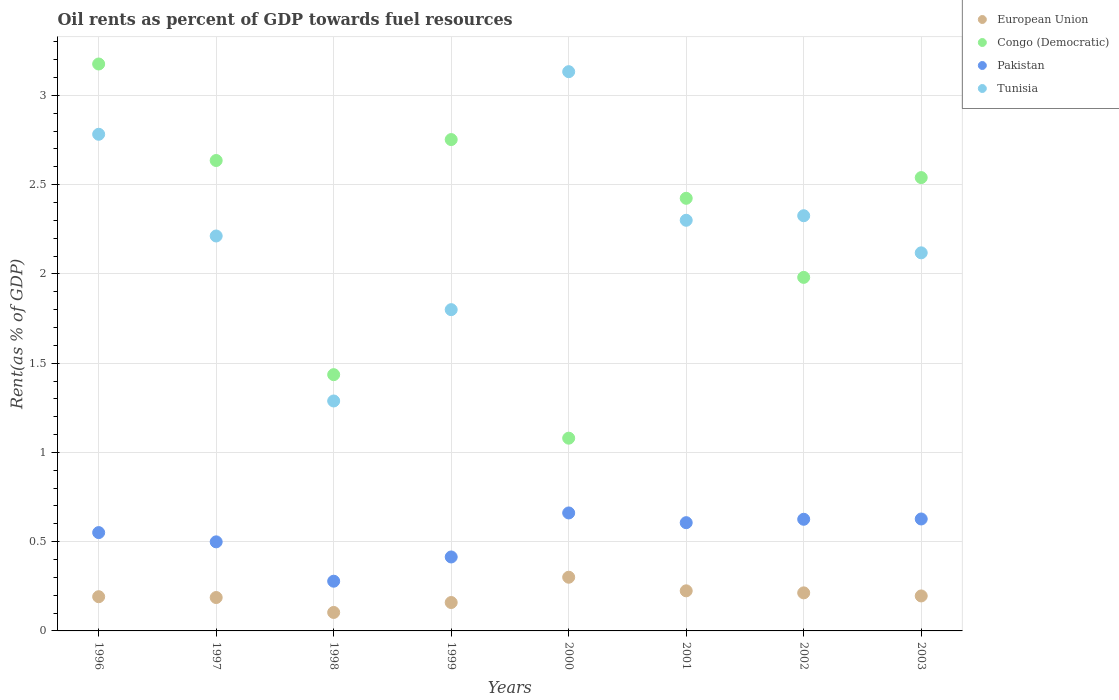What is the oil rent in European Union in 1998?
Offer a terse response. 0.1. Across all years, what is the maximum oil rent in Tunisia?
Provide a short and direct response. 3.13. Across all years, what is the minimum oil rent in Pakistan?
Offer a terse response. 0.28. In which year was the oil rent in Tunisia maximum?
Provide a short and direct response. 2000. In which year was the oil rent in Congo (Democratic) minimum?
Offer a very short reply. 2000. What is the total oil rent in Tunisia in the graph?
Your response must be concise. 17.96. What is the difference between the oil rent in European Union in 1997 and that in 2003?
Your answer should be compact. -0.01. What is the difference between the oil rent in Congo (Democratic) in 1998 and the oil rent in European Union in 2001?
Make the answer very short. 1.21. What is the average oil rent in Congo (Democratic) per year?
Your response must be concise. 2.25. In the year 2002, what is the difference between the oil rent in Pakistan and oil rent in Tunisia?
Your response must be concise. -1.7. In how many years, is the oil rent in Pakistan greater than 2.1 %?
Provide a succinct answer. 0. What is the ratio of the oil rent in Pakistan in 1998 to that in 2001?
Provide a succinct answer. 0.46. Is the oil rent in Pakistan in 1999 less than that in 2002?
Provide a succinct answer. Yes. Is the difference between the oil rent in Pakistan in 1996 and 1999 greater than the difference between the oil rent in Tunisia in 1996 and 1999?
Offer a very short reply. No. What is the difference between the highest and the second highest oil rent in European Union?
Ensure brevity in your answer.  0.08. What is the difference between the highest and the lowest oil rent in European Union?
Ensure brevity in your answer.  0.2. In how many years, is the oil rent in European Union greater than the average oil rent in European Union taken over all years?
Offer a very short reply. 3. Is it the case that in every year, the sum of the oil rent in Congo (Democratic) and oil rent in European Union  is greater than the sum of oil rent in Tunisia and oil rent in Pakistan?
Offer a terse response. No. Is the oil rent in Pakistan strictly less than the oil rent in European Union over the years?
Offer a very short reply. No. How many dotlines are there?
Make the answer very short. 4. What is the difference between two consecutive major ticks on the Y-axis?
Make the answer very short. 0.5. Does the graph contain any zero values?
Your response must be concise. No. Does the graph contain grids?
Provide a succinct answer. Yes. What is the title of the graph?
Your response must be concise. Oil rents as percent of GDP towards fuel resources. Does "Pakistan" appear as one of the legend labels in the graph?
Keep it short and to the point. Yes. What is the label or title of the Y-axis?
Make the answer very short. Rent(as % of GDP). What is the Rent(as % of GDP) in European Union in 1996?
Give a very brief answer. 0.19. What is the Rent(as % of GDP) in Congo (Democratic) in 1996?
Keep it short and to the point. 3.18. What is the Rent(as % of GDP) in Pakistan in 1996?
Offer a very short reply. 0.55. What is the Rent(as % of GDP) in Tunisia in 1996?
Offer a very short reply. 2.78. What is the Rent(as % of GDP) of European Union in 1997?
Offer a very short reply. 0.19. What is the Rent(as % of GDP) in Congo (Democratic) in 1997?
Provide a succinct answer. 2.64. What is the Rent(as % of GDP) in Pakistan in 1997?
Give a very brief answer. 0.5. What is the Rent(as % of GDP) in Tunisia in 1997?
Your answer should be compact. 2.21. What is the Rent(as % of GDP) in European Union in 1998?
Your answer should be compact. 0.1. What is the Rent(as % of GDP) of Congo (Democratic) in 1998?
Offer a very short reply. 1.44. What is the Rent(as % of GDP) of Pakistan in 1998?
Provide a short and direct response. 0.28. What is the Rent(as % of GDP) in Tunisia in 1998?
Your response must be concise. 1.29. What is the Rent(as % of GDP) of European Union in 1999?
Provide a short and direct response. 0.16. What is the Rent(as % of GDP) of Congo (Democratic) in 1999?
Your answer should be very brief. 2.75. What is the Rent(as % of GDP) of Pakistan in 1999?
Keep it short and to the point. 0.41. What is the Rent(as % of GDP) in Tunisia in 1999?
Offer a very short reply. 1.8. What is the Rent(as % of GDP) in European Union in 2000?
Your response must be concise. 0.3. What is the Rent(as % of GDP) of Congo (Democratic) in 2000?
Your answer should be very brief. 1.08. What is the Rent(as % of GDP) of Pakistan in 2000?
Offer a very short reply. 0.66. What is the Rent(as % of GDP) of Tunisia in 2000?
Keep it short and to the point. 3.13. What is the Rent(as % of GDP) in European Union in 2001?
Provide a short and direct response. 0.22. What is the Rent(as % of GDP) of Congo (Democratic) in 2001?
Offer a very short reply. 2.42. What is the Rent(as % of GDP) in Pakistan in 2001?
Keep it short and to the point. 0.61. What is the Rent(as % of GDP) of Tunisia in 2001?
Your response must be concise. 2.3. What is the Rent(as % of GDP) of European Union in 2002?
Make the answer very short. 0.21. What is the Rent(as % of GDP) in Congo (Democratic) in 2002?
Make the answer very short. 1.98. What is the Rent(as % of GDP) of Pakistan in 2002?
Your answer should be very brief. 0.63. What is the Rent(as % of GDP) in Tunisia in 2002?
Your answer should be very brief. 2.33. What is the Rent(as % of GDP) in European Union in 2003?
Your response must be concise. 0.2. What is the Rent(as % of GDP) in Congo (Democratic) in 2003?
Ensure brevity in your answer.  2.54. What is the Rent(as % of GDP) of Pakistan in 2003?
Your answer should be very brief. 0.63. What is the Rent(as % of GDP) in Tunisia in 2003?
Provide a short and direct response. 2.12. Across all years, what is the maximum Rent(as % of GDP) of European Union?
Offer a terse response. 0.3. Across all years, what is the maximum Rent(as % of GDP) in Congo (Democratic)?
Keep it short and to the point. 3.18. Across all years, what is the maximum Rent(as % of GDP) in Pakistan?
Make the answer very short. 0.66. Across all years, what is the maximum Rent(as % of GDP) of Tunisia?
Ensure brevity in your answer.  3.13. Across all years, what is the minimum Rent(as % of GDP) of European Union?
Your answer should be very brief. 0.1. Across all years, what is the minimum Rent(as % of GDP) of Congo (Democratic)?
Make the answer very short. 1.08. Across all years, what is the minimum Rent(as % of GDP) of Pakistan?
Your response must be concise. 0.28. Across all years, what is the minimum Rent(as % of GDP) in Tunisia?
Keep it short and to the point. 1.29. What is the total Rent(as % of GDP) in European Union in the graph?
Ensure brevity in your answer.  1.58. What is the total Rent(as % of GDP) of Congo (Democratic) in the graph?
Your answer should be compact. 18.02. What is the total Rent(as % of GDP) of Pakistan in the graph?
Keep it short and to the point. 4.26. What is the total Rent(as % of GDP) of Tunisia in the graph?
Provide a succinct answer. 17.96. What is the difference between the Rent(as % of GDP) in European Union in 1996 and that in 1997?
Provide a short and direct response. 0. What is the difference between the Rent(as % of GDP) of Congo (Democratic) in 1996 and that in 1997?
Provide a succinct answer. 0.54. What is the difference between the Rent(as % of GDP) of Pakistan in 1996 and that in 1997?
Provide a short and direct response. 0.05. What is the difference between the Rent(as % of GDP) of Tunisia in 1996 and that in 1997?
Provide a succinct answer. 0.57. What is the difference between the Rent(as % of GDP) in European Union in 1996 and that in 1998?
Ensure brevity in your answer.  0.09. What is the difference between the Rent(as % of GDP) in Congo (Democratic) in 1996 and that in 1998?
Provide a short and direct response. 1.74. What is the difference between the Rent(as % of GDP) of Pakistan in 1996 and that in 1998?
Your answer should be very brief. 0.27. What is the difference between the Rent(as % of GDP) of Tunisia in 1996 and that in 1998?
Offer a very short reply. 1.49. What is the difference between the Rent(as % of GDP) in European Union in 1996 and that in 1999?
Give a very brief answer. 0.03. What is the difference between the Rent(as % of GDP) of Congo (Democratic) in 1996 and that in 1999?
Provide a short and direct response. 0.42. What is the difference between the Rent(as % of GDP) of Pakistan in 1996 and that in 1999?
Your response must be concise. 0.14. What is the difference between the Rent(as % of GDP) of Tunisia in 1996 and that in 1999?
Offer a very short reply. 0.98. What is the difference between the Rent(as % of GDP) of European Union in 1996 and that in 2000?
Make the answer very short. -0.11. What is the difference between the Rent(as % of GDP) in Congo (Democratic) in 1996 and that in 2000?
Ensure brevity in your answer.  2.1. What is the difference between the Rent(as % of GDP) in Pakistan in 1996 and that in 2000?
Your response must be concise. -0.11. What is the difference between the Rent(as % of GDP) of Tunisia in 1996 and that in 2000?
Offer a terse response. -0.35. What is the difference between the Rent(as % of GDP) of European Union in 1996 and that in 2001?
Your answer should be compact. -0.03. What is the difference between the Rent(as % of GDP) in Congo (Democratic) in 1996 and that in 2001?
Offer a very short reply. 0.75. What is the difference between the Rent(as % of GDP) of Pakistan in 1996 and that in 2001?
Your response must be concise. -0.06. What is the difference between the Rent(as % of GDP) of Tunisia in 1996 and that in 2001?
Keep it short and to the point. 0.48. What is the difference between the Rent(as % of GDP) of European Union in 1996 and that in 2002?
Provide a short and direct response. -0.02. What is the difference between the Rent(as % of GDP) of Congo (Democratic) in 1996 and that in 2002?
Make the answer very short. 1.2. What is the difference between the Rent(as % of GDP) in Pakistan in 1996 and that in 2002?
Your response must be concise. -0.07. What is the difference between the Rent(as % of GDP) of Tunisia in 1996 and that in 2002?
Ensure brevity in your answer.  0.46. What is the difference between the Rent(as % of GDP) in European Union in 1996 and that in 2003?
Make the answer very short. -0. What is the difference between the Rent(as % of GDP) in Congo (Democratic) in 1996 and that in 2003?
Ensure brevity in your answer.  0.64. What is the difference between the Rent(as % of GDP) in Pakistan in 1996 and that in 2003?
Keep it short and to the point. -0.08. What is the difference between the Rent(as % of GDP) of Tunisia in 1996 and that in 2003?
Ensure brevity in your answer.  0.66. What is the difference between the Rent(as % of GDP) in European Union in 1997 and that in 1998?
Offer a terse response. 0.08. What is the difference between the Rent(as % of GDP) in Congo (Democratic) in 1997 and that in 1998?
Keep it short and to the point. 1.2. What is the difference between the Rent(as % of GDP) in Pakistan in 1997 and that in 1998?
Your answer should be compact. 0.22. What is the difference between the Rent(as % of GDP) in Tunisia in 1997 and that in 1998?
Offer a terse response. 0.92. What is the difference between the Rent(as % of GDP) of European Union in 1997 and that in 1999?
Make the answer very short. 0.03. What is the difference between the Rent(as % of GDP) in Congo (Democratic) in 1997 and that in 1999?
Offer a very short reply. -0.12. What is the difference between the Rent(as % of GDP) of Pakistan in 1997 and that in 1999?
Provide a succinct answer. 0.08. What is the difference between the Rent(as % of GDP) in Tunisia in 1997 and that in 1999?
Your answer should be compact. 0.41. What is the difference between the Rent(as % of GDP) in European Union in 1997 and that in 2000?
Your answer should be very brief. -0.11. What is the difference between the Rent(as % of GDP) of Congo (Democratic) in 1997 and that in 2000?
Provide a short and direct response. 1.56. What is the difference between the Rent(as % of GDP) in Pakistan in 1997 and that in 2000?
Provide a short and direct response. -0.16. What is the difference between the Rent(as % of GDP) of Tunisia in 1997 and that in 2000?
Ensure brevity in your answer.  -0.92. What is the difference between the Rent(as % of GDP) of European Union in 1997 and that in 2001?
Provide a short and direct response. -0.04. What is the difference between the Rent(as % of GDP) in Congo (Democratic) in 1997 and that in 2001?
Make the answer very short. 0.21. What is the difference between the Rent(as % of GDP) of Pakistan in 1997 and that in 2001?
Keep it short and to the point. -0.11. What is the difference between the Rent(as % of GDP) of Tunisia in 1997 and that in 2001?
Ensure brevity in your answer.  -0.09. What is the difference between the Rent(as % of GDP) of European Union in 1997 and that in 2002?
Ensure brevity in your answer.  -0.03. What is the difference between the Rent(as % of GDP) of Congo (Democratic) in 1997 and that in 2002?
Provide a short and direct response. 0.65. What is the difference between the Rent(as % of GDP) in Pakistan in 1997 and that in 2002?
Provide a short and direct response. -0.13. What is the difference between the Rent(as % of GDP) of Tunisia in 1997 and that in 2002?
Offer a very short reply. -0.11. What is the difference between the Rent(as % of GDP) of European Union in 1997 and that in 2003?
Give a very brief answer. -0.01. What is the difference between the Rent(as % of GDP) in Congo (Democratic) in 1997 and that in 2003?
Offer a very short reply. 0.1. What is the difference between the Rent(as % of GDP) in Pakistan in 1997 and that in 2003?
Provide a short and direct response. -0.13. What is the difference between the Rent(as % of GDP) in Tunisia in 1997 and that in 2003?
Your answer should be compact. 0.09. What is the difference between the Rent(as % of GDP) in European Union in 1998 and that in 1999?
Keep it short and to the point. -0.06. What is the difference between the Rent(as % of GDP) of Congo (Democratic) in 1998 and that in 1999?
Provide a short and direct response. -1.32. What is the difference between the Rent(as % of GDP) in Pakistan in 1998 and that in 1999?
Your answer should be compact. -0.14. What is the difference between the Rent(as % of GDP) in Tunisia in 1998 and that in 1999?
Provide a succinct answer. -0.51. What is the difference between the Rent(as % of GDP) in European Union in 1998 and that in 2000?
Ensure brevity in your answer.  -0.2. What is the difference between the Rent(as % of GDP) of Congo (Democratic) in 1998 and that in 2000?
Offer a terse response. 0.36. What is the difference between the Rent(as % of GDP) of Pakistan in 1998 and that in 2000?
Your response must be concise. -0.38. What is the difference between the Rent(as % of GDP) in Tunisia in 1998 and that in 2000?
Give a very brief answer. -1.84. What is the difference between the Rent(as % of GDP) of European Union in 1998 and that in 2001?
Your answer should be very brief. -0.12. What is the difference between the Rent(as % of GDP) of Congo (Democratic) in 1998 and that in 2001?
Your answer should be compact. -0.99. What is the difference between the Rent(as % of GDP) of Pakistan in 1998 and that in 2001?
Give a very brief answer. -0.33. What is the difference between the Rent(as % of GDP) in Tunisia in 1998 and that in 2001?
Provide a succinct answer. -1.01. What is the difference between the Rent(as % of GDP) of European Union in 1998 and that in 2002?
Offer a terse response. -0.11. What is the difference between the Rent(as % of GDP) of Congo (Democratic) in 1998 and that in 2002?
Your answer should be compact. -0.55. What is the difference between the Rent(as % of GDP) in Pakistan in 1998 and that in 2002?
Ensure brevity in your answer.  -0.35. What is the difference between the Rent(as % of GDP) in Tunisia in 1998 and that in 2002?
Offer a very short reply. -1.04. What is the difference between the Rent(as % of GDP) of European Union in 1998 and that in 2003?
Your response must be concise. -0.09. What is the difference between the Rent(as % of GDP) in Congo (Democratic) in 1998 and that in 2003?
Ensure brevity in your answer.  -1.1. What is the difference between the Rent(as % of GDP) of Pakistan in 1998 and that in 2003?
Offer a terse response. -0.35. What is the difference between the Rent(as % of GDP) of Tunisia in 1998 and that in 2003?
Offer a terse response. -0.83. What is the difference between the Rent(as % of GDP) in European Union in 1999 and that in 2000?
Your answer should be very brief. -0.14. What is the difference between the Rent(as % of GDP) in Congo (Democratic) in 1999 and that in 2000?
Give a very brief answer. 1.67. What is the difference between the Rent(as % of GDP) in Pakistan in 1999 and that in 2000?
Ensure brevity in your answer.  -0.25. What is the difference between the Rent(as % of GDP) in Tunisia in 1999 and that in 2000?
Give a very brief answer. -1.33. What is the difference between the Rent(as % of GDP) in European Union in 1999 and that in 2001?
Provide a short and direct response. -0.07. What is the difference between the Rent(as % of GDP) of Congo (Democratic) in 1999 and that in 2001?
Give a very brief answer. 0.33. What is the difference between the Rent(as % of GDP) in Pakistan in 1999 and that in 2001?
Keep it short and to the point. -0.19. What is the difference between the Rent(as % of GDP) in Tunisia in 1999 and that in 2001?
Keep it short and to the point. -0.5. What is the difference between the Rent(as % of GDP) of European Union in 1999 and that in 2002?
Your answer should be very brief. -0.05. What is the difference between the Rent(as % of GDP) in Congo (Democratic) in 1999 and that in 2002?
Provide a short and direct response. 0.77. What is the difference between the Rent(as % of GDP) of Pakistan in 1999 and that in 2002?
Keep it short and to the point. -0.21. What is the difference between the Rent(as % of GDP) in Tunisia in 1999 and that in 2002?
Your answer should be compact. -0.53. What is the difference between the Rent(as % of GDP) in European Union in 1999 and that in 2003?
Your response must be concise. -0.04. What is the difference between the Rent(as % of GDP) in Congo (Democratic) in 1999 and that in 2003?
Your answer should be very brief. 0.21. What is the difference between the Rent(as % of GDP) of Pakistan in 1999 and that in 2003?
Offer a very short reply. -0.21. What is the difference between the Rent(as % of GDP) of Tunisia in 1999 and that in 2003?
Provide a short and direct response. -0.32. What is the difference between the Rent(as % of GDP) of European Union in 2000 and that in 2001?
Provide a succinct answer. 0.08. What is the difference between the Rent(as % of GDP) in Congo (Democratic) in 2000 and that in 2001?
Your answer should be compact. -1.34. What is the difference between the Rent(as % of GDP) in Pakistan in 2000 and that in 2001?
Offer a terse response. 0.05. What is the difference between the Rent(as % of GDP) in Tunisia in 2000 and that in 2001?
Provide a succinct answer. 0.83. What is the difference between the Rent(as % of GDP) of European Union in 2000 and that in 2002?
Offer a very short reply. 0.09. What is the difference between the Rent(as % of GDP) in Congo (Democratic) in 2000 and that in 2002?
Keep it short and to the point. -0.9. What is the difference between the Rent(as % of GDP) of Pakistan in 2000 and that in 2002?
Offer a terse response. 0.04. What is the difference between the Rent(as % of GDP) of Tunisia in 2000 and that in 2002?
Offer a very short reply. 0.81. What is the difference between the Rent(as % of GDP) in European Union in 2000 and that in 2003?
Offer a terse response. 0.1. What is the difference between the Rent(as % of GDP) of Congo (Democratic) in 2000 and that in 2003?
Your answer should be very brief. -1.46. What is the difference between the Rent(as % of GDP) of Pakistan in 2000 and that in 2003?
Provide a short and direct response. 0.03. What is the difference between the Rent(as % of GDP) in Tunisia in 2000 and that in 2003?
Your answer should be compact. 1.01. What is the difference between the Rent(as % of GDP) in European Union in 2001 and that in 2002?
Your response must be concise. 0.01. What is the difference between the Rent(as % of GDP) in Congo (Democratic) in 2001 and that in 2002?
Make the answer very short. 0.44. What is the difference between the Rent(as % of GDP) of Pakistan in 2001 and that in 2002?
Your answer should be compact. -0.02. What is the difference between the Rent(as % of GDP) in Tunisia in 2001 and that in 2002?
Make the answer very short. -0.03. What is the difference between the Rent(as % of GDP) in European Union in 2001 and that in 2003?
Give a very brief answer. 0.03. What is the difference between the Rent(as % of GDP) of Congo (Democratic) in 2001 and that in 2003?
Give a very brief answer. -0.12. What is the difference between the Rent(as % of GDP) in Pakistan in 2001 and that in 2003?
Your answer should be very brief. -0.02. What is the difference between the Rent(as % of GDP) in Tunisia in 2001 and that in 2003?
Give a very brief answer. 0.18. What is the difference between the Rent(as % of GDP) in European Union in 2002 and that in 2003?
Offer a very short reply. 0.02. What is the difference between the Rent(as % of GDP) in Congo (Democratic) in 2002 and that in 2003?
Offer a terse response. -0.56. What is the difference between the Rent(as % of GDP) of Pakistan in 2002 and that in 2003?
Offer a very short reply. -0. What is the difference between the Rent(as % of GDP) of Tunisia in 2002 and that in 2003?
Provide a succinct answer. 0.21. What is the difference between the Rent(as % of GDP) in European Union in 1996 and the Rent(as % of GDP) in Congo (Democratic) in 1997?
Your answer should be very brief. -2.44. What is the difference between the Rent(as % of GDP) of European Union in 1996 and the Rent(as % of GDP) of Pakistan in 1997?
Make the answer very short. -0.31. What is the difference between the Rent(as % of GDP) in European Union in 1996 and the Rent(as % of GDP) in Tunisia in 1997?
Your answer should be compact. -2.02. What is the difference between the Rent(as % of GDP) in Congo (Democratic) in 1996 and the Rent(as % of GDP) in Pakistan in 1997?
Offer a very short reply. 2.68. What is the difference between the Rent(as % of GDP) in Congo (Democratic) in 1996 and the Rent(as % of GDP) in Tunisia in 1997?
Offer a terse response. 0.96. What is the difference between the Rent(as % of GDP) in Pakistan in 1996 and the Rent(as % of GDP) in Tunisia in 1997?
Provide a succinct answer. -1.66. What is the difference between the Rent(as % of GDP) in European Union in 1996 and the Rent(as % of GDP) in Congo (Democratic) in 1998?
Ensure brevity in your answer.  -1.24. What is the difference between the Rent(as % of GDP) of European Union in 1996 and the Rent(as % of GDP) of Pakistan in 1998?
Keep it short and to the point. -0.09. What is the difference between the Rent(as % of GDP) of European Union in 1996 and the Rent(as % of GDP) of Tunisia in 1998?
Provide a succinct answer. -1.1. What is the difference between the Rent(as % of GDP) in Congo (Democratic) in 1996 and the Rent(as % of GDP) in Pakistan in 1998?
Provide a short and direct response. 2.9. What is the difference between the Rent(as % of GDP) of Congo (Democratic) in 1996 and the Rent(as % of GDP) of Tunisia in 1998?
Offer a terse response. 1.89. What is the difference between the Rent(as % of GDP) of Pakistan in 1996 and the Rent(as % of GDP) of Tunisia in 1998?
Your response must be concise. -0.74. What is the difference between the Rent(as % of GDP) in European Union in 1996 and the Rent(as % of GDP) in Congo (Democratic) in 1999?
Provide a succinct answer. -2.56. What is the difference between the Rent(as % of GDP) in European Union in 1996 and the Rent(as % of GDP) in Pakistan in 1999?
Provide a short and direct response. -0.22. What is the difference between the Rent(as % of GDP) in European Union in 1996 and the Rent(as % of GDP) in Tunisia in 1999?
Offer a terse response. -1.61. What is the difference between the Rent(as % of GDP) of Congo (Democratic) in 1996 and the Rent(as % of GDP) of Pakistan in 1999?
Offer a terse response. 2.76. What is the difference between the Rent(as % of GDP) in Congo (Democratic) in 1996 and the Rent(as % of GDP) in Tunisia in 1999?
Your answer should be compact. 1.38. What is the difference between the Rent(as % of GDP) of Pakistan in 1996 and the Rent(as % of GDP) of Tunisia in 1999?
Offer a very short reply. -1.25. What is the difference between the Rent(as % of GDP) in European Union in 1996 and the Rent(as % of GDP) in Congo (Democratic) in 2000?
Give a very brief answer. -0.89. What is the difference between the Rent(as % of GDP) of European Union in 1996 and the Rent(as % of GDP) of Pakistan in 2000?
Your answer should be very brief. -0.47. What is the difference between the Rent(as % of GDP) of European Union in 1996 and the Rent(as % of GDP) of Tunisia in 2000?
Make the answer very short. -2.94. What is the difference between the Rent(as % of GDP) in Congo (Democratic) in 1996 and the Rent(as % of GDP) in Pakistan in 2000?
Keep it short and to the point. 2.51. What is the difference between the Rent(as % of GDP) in Congo (Democratic) in 1996 and the Rent(as % of GDP) in Tunisia in 2000?
Give a very brief answer. 0.04. What is the difference between the Rent(as % of GDP) in Pakistan in 1996 and the Rent(as % of GDP) in Tunisia in 2000?
Give a very brief answer. -2.58. What is the difference between the Rent(as % of GDP) of European Union in 1996 and the Rent(as % of GDP) of Congo (Democratic) in 2001?
Your response must be concise. -2.23. What is the difference between the Rent(as % of GDP) in European Union in 1996 and the Rent(as % of GDP) in Pakistan in 2001?
Your answer should be very brief. -0.41. What is the difference between the Rent(as % of GDP) of European Union in 1996 and the Rent(as % of GDP) of Tunisia in 2001?
Keep it short and to the point. -2.11. What is the difference between the Rent(as % of GDP) in Congo (Democratic) in 1996 and the Rent(as % of GDP) in Pakistan in 2001?
Keep it short and to the point. 2.57. What is the difference between the Rent(as % of GDP) of Congo (Democratic) in 1996 and the Rent(as % of GDP) of Tunisia in 2001?
Make the answer very short. 0.88. What is the difference between the Rent(as % of GDP) in Pakistan in 1996 and the Rent(as % of GDP) in Tunisia in 2001?
Offer a very short reply. -1.75. What is the difference between the Rent(as % of GDP) of European Union in 1996 and the Rent(as % of GDP) of Congo (Democratic) in 2002?
Give a very brief answer. -1.79. What is the difference between the Rent(as % of GDP) in European Union in 1996 and the Rent(as % of GDP) in Pakistan in 2002?
Provide a short and direct response. -0.43. What is the difference between the Rent(as % of GDP) of European Union in 1996 and the Rent(as % of GDP) of Tunisia in 2002?
Keep it short and to the point. -2.13. What is the difference between the Rent(as % of GDP) in Congo (Democratic) in 1996 and the Rent(as % of GDP) in Pakistan in 2002?
Offer a very short reply. 2.55. What is the difference between the Rent(as % of GDP) of Congo (Democratic) in 1996 and the Rent(as % of GDP) of Tunisia in 2002?
Your response must be concise. 0.85. What is the difference between the Rent(as % of GDP) in Pakistan in 1996 and the Rent(as % of GDP) in Tunisia in 2002?
Provide a short and direct response. -1.77. What is the difference between the Rent(as % of GDP) of European Union in 1996 and the Rent(as % of GDP) of Congo (Democratic) in 2003?
Ensure brevity in your answer.  -2.35. What is the difference between the Rent(as % of GDP) of European Union in 1996 and the Rent(as % of GDP) of Pakistan in 2003?
Your response must be concise. -0.44. What is the difference between the Rent(as % of GDP) of European Union in 1996 and the Rent(as % of GDP) of Tunisia in 2003?
Your response must be concise. -1.93. What is the difference between the Rent(as % of GDP) of Congo (Democratic) in 1996 and the Rent(as % of GDP) of Pakistan in 2003?
Ensure brevity in your answer.  2.55. What is the difference between the Rent(as % of GDP) of Congo (Democratic) in 1996 and the Rent(as % of GDP) of Tunisia in 2003?
Provide a succinct answer. 1.06. What is the difference between the Rent(as % of GDP) of Pakistan in 1996 and the Rent(as % of GDP) of Tunisia in 2003?
Provide a succinct answer. -1.57. What is the difference between the Rent(as % of GDP) of European Union in 1997 and the Rent(as % of GDP) of Congo (Democratic) in 1998?
Your response must be concise. -1.25. What is the difference between the Rent(as % of GDP) in European Union in 1997 and the Rent(as % of GDP) in Pakistan in 1998?
Provide a short and direct response. -0.09. What is the difference between the Rent(as % of GDP) of European Union in 1997 and the Rent(as % of GDP) of Tunisia in 1998?
Keep it short and to the point. -1.1. What is the difference between the Rent(as % of GDP) in Congo (Democratic) in 1997 and the Rent(as % of GDP) in Pakistan in 1998?
Provide a succinct answer. 2.36. What is the difference between the Rent(as % of GDP) of Congo (Democratic) in 1997 and the Rent(as % of GDP) of Tunisia in 1998?
Make the answer very short. 1.35. What is the difference between the Rent(as % of GDP) in Pakistan in 1997 and the Rent(as % of GDP) in Tunisia in 1998?
Ensure brevity in your answer.  -0.79. What is the difference between the Rent(as % of GDP) in European Union in 1997 and the Rent(as % of GDP) in Congo (Democratic) in 1999?
Provide a short and direct response. -2.57. What is the difference between the Rent(as % of GDP) of European Union in 1997 and the Rent(as % of GDP) of Pakistan in 1999?
Your response must be concise. -0.23. What is the difference between the Rent(as % of GDP) of European Union in 1997 and the Rent(as % of GDP) of Tunisia in 1999?
Ensure brevity in your answer.  -1.61. What is the difference between the Rent(as % of GDP) in Congo (Democratic) in 1997 and the Rent(as % of GDP) in Pakistan in 1999?
Keep it short and to the point. 2.22. What is the difference between the Rent(as % of GDP) of Congo (Democratic) in 1997 and the Rent(as % of GDP) of Tunisia in 1999?
Offer a terse response. 0.84. What is the difference between the Rent(as % of GDP) of Pakistan in 1997 and the Rent(as % of GDP) of Tunisia in 1999?
Your response must be concise. -1.3. What is the difference between the Rent(as % of GDP) in European Union in 1997 and the Rent(as % of GDP) in Congo (Democratic) in 2000?
Offer a very short reply. -0.89. What is the difference between the Rent(as % of GDP) in European Union in 1997 and the Rent(as % of GDP) in Pakistan in 2000?
Offer a terse response. -0.47. What is the difference between the Rent(as % of GDP) of European Union in 1997 and the Rent(as % of GDP) of Tunisia in 2000?
Keep it short and to the point. -2.95. What is the difference between the Rent(as % of GDP) of Congo (Democratic) in 1997 and the Rent(as % of GDP) of Pakistan in 2000?
Provide a short and direct response. 1.97. What is the difference between the Rent(as % of GDP) in Congo (Democratic) in 1997 and the Rent(as % of GDP) in Tunisia in 2000?
Your answer should be very brief. -0.5. What is the difference between the Rent(as % of GDP) in Pakistan in 1997 and the Rent(as % of GDP) in Tunisia in 2000?
Your response must be concise. -2.63. What is the difference between the Rent(as % of GDP) of European Union in 1997 and the Rent(as % of GDP) of Congo (Democratic) in 2001?
Provide a succinct answer. -2.24. What is the difference between the Rent(as % of GDP) of European Union in 1997 and the Rent(as % of GDP) of Pakistan in 2001?
Your answer should be very brief. -0.42. What is the difference between the Rent(as % of GDP) of European Union in 1997 and the Rent(as % of GDP) of Tunisia in 2001?
Keep it short and to the point. -2.11. What is the difference between the Rent(as % of GDP) in Congo (Democratic) in 1997 and the Rent(as % of GDP) in Pakistan in 2001?
Your response must be concise. 2.03. What is the difference between the Rent(as % of GDP) in Congo (Democratic) in 1997 and the Rent(as % of GDP) in Tunisia in 2001?
Offer a terse response. 0.33. What is the difference between the Rent(as % of GDP) in Pakistan in 1997 and the Rent(as % of GDP) in Tunisia in 2001?
Your response must be concise. -1.8. What is the difference between the Rent(as % of GDP) of European Union in 1997 and the Rent(as % of GDP) of Congo (Democratic) in 2002?
Give a very brief answer. -1.79. What is the difference between the Rent(as % of GDP) of European Union in 1997 and the Rent(as % of GDP) of Pakistan in 2002?
Ensure brevity in your answer.  -0.44. What is the difference between the Rent(as % of GDP) of European Union in 1997 and the Rent(as % of GDP) of Tunisia in 2002?
Your answer should be compact. -2.14. What is the difference between the Rent(as % of GDP) in Congo (Democratic) in 1997 and the Rent(as % of GDP) in Pakistan in 2002?
Provide a succinct answer. 2.01. What is the difference between the Rent(as % of GDP) of Congo (Democratic) in 1997 and the Rent(as % of GDP) of Tunisia in 2002?
Your answer should be very brief. 0.31. What is the difference between the Rent(as % of GDP) of Pakistan in 1997 and the Rent(as % of GDP) of Tunisia in 2002?
Offer a terse response. -1.83. What is the difference between the Rent(as % of GDP) of European Union in 1997 and the Rent(as % of GDP) of Congo (Democratic) in 2003?
Your answer should be very brief. -2.35. What is the difference between the Rent(as % of GDP) in European Union in 1997 and the Rent(as % of GDP) in Pakistan in 2003?
Your answer should be compact. -0.44. What is the difference between the Rent(as % of GDP) in European Union in 1997 and the Rent(as % of GDP) in Tunisia in 2003?
Provide a succinct answer. -1.93. What is the difference between the Rent(as % of GDP) of Congo (Democratic) in 1997 and the Rent(as % of GDP) of Pakistan in 2003?
Ensure brevity in your answer.  2.01. What is the difference between the Rent(as % of GDP) of Congo (Democratic) in 1997 and the Rent(as % of GDP) of Tunisia in 2003?
Offer a very short reply. 0.52. What is the difference between the Rent(as % of GDP) of Pakistan in 1997 and the Rent(as % of GDP) of Tunisia in 2003?
Provide a succinct answer. -1.62. What is the difference between the Rent(as % of GDP) in European Union in 1998 and the Rent(as % of GDP) in Congo (Democratic) in 1999?
Provide a short and direct response. -2.65. What is the difference between the Rent(as % of GDP) in European Union in 1998 and the Rent(as % of GDP) in Pakistan in 1999?
Your answer should be very brief. -0.31. What is the difference between the Rent(as % of GDP) of European Union in 1998 and the Rent(as % of GDP) of Tunisia in 1999?
Give a very brief answer. -1.7. What is the difference between the Rent(as % of GDP) of Congo (Democratic) in 1998 and the Rent(as % of GDP) of Pakistan in 1999?
Ensure brevity in your answer.  1.02. What is the difference between the Rent(as % of GDP) of Congo (Democratic) in 1998 and the Rent(as % of GDP) of Tunisia in 1999?
Your answer should be compact. -0.36. What is the difference between the Rent(as % of GDP) in Pakistan in 1998 and the Rent(as % of GDP) in Tunisia in 1999?
Give a very brief answer. -1.52. What is the difference between the Rent(as % of GDP) in European Union in 1998 and the Rent(as % of GDP) in Congo (Democratic) in 2000?
Provide a succinct answer. -0.98. What is the difference between the Rent(as % of GDP) in European Union in 1998 and the Rent(as % of GDP) in Pakistan in 2000?
Provide a short and direct response. -0.56. What is the difference between the Rent(as % of GDP) of European Union in 1998 and the Rent(as % of GDP) of Tunisia in 2000?
Provide a short and direct response. -3.03. What is the difference between the Rent(as % of GDP) of Congo (Democratic) in 1998 and the Rent(as % of GDP) of Pakistan in 2000?
Make the answer very short. 0.77. What is the difference between the Rent(as % of GDP) in Congo (Democratic) in 1998 and the Rent(as % of GDP) in Tunisia in 2000?
Your response must be concise. -1.7. What is the difference between the Rent(as % of GDP) in Pakistan in 1998 and the Rent(as % of GDP) in Tunisia in 2000?
Ensure brevity in your answer.  -2.85. What is the difference between the Rent(as % of GDP) in European Union in 1998 and the Rent(as % of GDP) in Congo (Democratic) in 2001?
Your response must be concise. -2.32. What is the difference between the Rent(as % of GDP) in European Union in 1998 and the Rent(as % of GDP) in Pakistan in 2001?
Keep it short and to the point. -0.5. What is the difference between the Rent(as % of GDP) of European Union in 1998 and the Rent(as % of GDP) of Tunisia in 2001?
Provide a short and direct response. -2.2. What is the difference between the Rent(as % of GDP) in Congo (Democratic) in 1998 and the Rent(as % of GDP) in Pakistan in 2001?
Provide a short and direct response. 0.83. What is the difference between the Rent(as % of GDP) in Congo (Democratic) in 1998 and the Rent(as % of GDP) in Tunisia in 2001?
Your answer should be very brief. -0.86. What is the difference between the Rent(as % of GDP) of Pakistan in 1998 and the Rent(as % of GDP) of Tunisia in 2001?
Make the answer very short. -2.02. What is the difference between the Rent(as % of GDP) of European Union in 1998 and the Rent(as % of GDP) of Congo (Democratic) in 2002?
Provide a succinct answer. -1.88. What is the difference between the Rent(as % of GDP) of European Union in 1998 and the Rent(as % of GDP) of Pakistan in 2002?
Your response must be concise. -0.52. What is the difference between the Rent(as % of GDP) in European Union in 1998 and the Rent(as % of GDP) in Tunisia in 2002?
Make the answer very short. -2.22. What is the difference between the Rent(as % of GDP) in Congo (Democratic) in 1998 and the Rent(as % of GDP) in Pakistan in 2002?
Provide a succinct answer. 0.81. What is the difference between the Rent(as % of GDP) in Congo (Democratic) in 1998 and the Rent(as % of GDP) in Tunisia in 2002?
Your answer should be very brief. -0.89. What is the difference between the Rent(as % of GDP) in Pakistan in 1998 and the Rent(as % of GDP) in Tunisia in 2002?
Keep it short and to the point. -2.05. What is the difference between the Rent(as % of GDP) of European Union in 1998 and the Rent(as % of GDP) of Congo (Democratic) in 2003?
Your answer should be compact. -2.44. What is the difference between the Rent(as % of GDP) of European Union in 1998 and the Rent(as % of GDP) of Pakistan in 2003?
Your answer should be very brief. -0.52. What is the difference between the Rent(as % of GDP) in European Union in 1998 and the Rent(as % of GDP) in Tunisia in 2003?
Keep it short and to the point. -2.01. What is the difference between the Rent(as % of GDP) in Congo (Democratic) in 1998 and the Rent(as % of GDP) in Pakistan in 2003?
Ensure brevity in your answer.  0.81. What is the difference between the Rent(as % of GDP) in Congo (Democratic) in 1998 and the Rent(as % of GDP) in Tunisia in 2003?
Your answer should be very brief. -0.68. What is the difference between the Rent(as % of GDP) in Pakistan in 1998 and the Rent(as % of GDP) in Tunisia in 2003?
Provide a short and direct response. -1.84. What is the difference between the Rent(as % of GDP) of European Union in 1999 and the Rent(as % of GDP) of Congo (Democratic) in 2000?
Ensure brevity in your answer.  -0.92. What is the difference between the Rent(as % of GDP) of European Union in 1999 and the Rent(as % of GDP) of Pakistan in 2000?
Offer a very short reply. -0.5. What is the difference between the Rent(as % of GDP) in European Union in 1999 and the Rent(as % of GDP) in Tunisia in 2000?
Offer a very short reply. -2.97. What is the difference between the Rent(as % of GDP) in Congo (Democratic) in 1999 and the Rent(as % of GDP) in Pakistan in 2000?
Make the answer very short. 2.09. What is the difference between the Rent(as % of GDP) in Congo (Democratic) in 1999 and the Rent(as % of GDP) in Tunisia in 2000?
Offer a terse response. -0.38. What is the difference between the Rent(as % of GDP) of Pakistan in 1999 and the Rent(as % of GDP) of Tunisia in 2000?
Your answer should be compact. -2.72. What is the difference between the Rent(as % of GDP) of European Union in 1999 and the Rent(as % of GDP) of Congo (Democratic) in 2001?
Provide a succinct answer. -2.26. What is the difference between the Rent(as % of GDP) of European Union in 1999 and the Rent(as % of GDP) of Pakistan in 2001?
Your answer should be very brief. -0.45. What is the difference between the Rent(as % of GDP) in European Union in 1999 and the Rent(as % of GDP) in Tunisia in 2001?
Offer a very short reply. -2.14. What is the difference between the Rent(as % of GDP) of Congo (Democratic) in 1999 and the Rent(as % of GDP) of Pakistan in 2001?
Your response must be concise. 2.15. What is the difference between the Rent(as % of GDP) in Congo (Democratic) in 1999 and the Rent(as % of GDP) in Tunisia in 2001?
Give a very brief answer. 0.45. What is the difference between the Rent(as % of GDP) in Pakistan in 1999 and the Rent(as % of GDP) in Tunisia in 2001?
Provide a short and direct response. -1.89. What is the difference between the Rent(as % of GDP) in European Union in 1999 and the Rent(as % of GDP) in Congo (Democratic) in 2002?
Keep it short and to the point. -1.82. What is the difference between the Rent(as % of GDP) in European Union in 1999 and the Rent(as % of GDP) in Pakistan in 2002?
Give a very brief answer. -0.47. What is the difference between the Rent(as % of GDP) of European Union in 1999 and the Rent(as % of GDP) of Tunisia in 2002?
Offer a very short reply. -2.17. What is the difference between the Rent(as % of GDP) in Congo (Democratic) in 1999 and the Rent(as % of GDP) in Pakistan in 2002?
Ensure brevity in your answer.  2.13. What is the difference between the Rent(as % of GDP) of Congo (Democratic) in 1999 and the Rent(as % of GDP) of Tunisia in 2002?
Offer a very short reply. 0.43. What is the difference between the Rent(as % of GDP) in Pakistan in 1999 and the Rent(as % of GDP) in Tunisia in 2002?
Your response must be concise. -1.91. What is the difference between the Rent(as % of GDP) of European Union in 1999 and the Rent(as % of GDP) of Congo (Democratic) in 2003?
Provide a short and direct response. -2.38. What is the difference between the Rent(as % of GDP) of European Union in 1999 and the Rent(as % of GDP) of Pakistan in 2003?
Keep it short and to the point. -0.47. What is the difference between the Rent(as % of GDP) of European Union in 1999 and the Rent(as % of GDP) of Tunisia in 2003?
Give a very brief answer. -1.96. What is the difference between the Rent(as % of GDP) in Congo (Democratic) in 1999 and the Rent(as % of GDP) in Pakistan in 2003?
Your answer should be compact. 2.13. What is the difference between the Rent(as % of GDP) in Congo (Democratic) in 1999 and the Rent(as % of GDP) in Tunisia in 2003?
Keep it short and to the point. 0.63. What is the difference between the Rent(as % of GDP) in Pakistan in 1999 and the Rent(as % of GDP) in Tunisia in 2003?
Make the answer very short. -1.7. What is the difference between the Rent(as % of GDP) of European Union in 2000 and the Rent(as % of GDP) of Congo (Democratic) in 2001?
Make the answer very short. -2.12. What is the difference between the Rent(as % of GDP) of European Union in 2000 and the Rent(as % of GDP) of Pakistan in 2001?
Your response must be concise. -0.31. What is the difference between the Rent(as % of GDP) of European Union in 2000 and the Rent(as % of GDP) of Tunisia in 2001?
Your answer should be compact. -2. What is the difference between the Rent(as % of GDP) in Congo (Democratic) in 2000 and the Rent(as % of GDP) in Pakistan in 2001?
Keep it short and to the point. 0.47. What is the difference between the Rent(as % of GDP) in Congo (Democratic) in 2000 and the Rent(as % of GDP) in Tunisia in 2001?
Offer a terse response. -1.22. What is the difference between the Rent(as % of GDP) in Pakistan in 2000 and the Rent(as % of GDP) in Tunisia in 2001?
Offer a terse response. -1.64. What is the difference between the Rent(as % of GDP) in European Union in 2000 and the Rent(as % of GDP) in Congo (Democratic) in 2002?
Offer a very short reply. -1.68. What is the difference between the Rent(as % of GDP) in European Union in 2000 and the Rent(as % of GDP) in Pakistan in 2002?
Ensure brevity in your answer.  -0.32. What is the difference between the Rent(as % of GDP) of European Union in 2000 and the Rent(as % of GDP) of Tunisia in 2002?
Keep it short and to the point. -2.03. What is the difference between the Rent(as % of GDP) in Congo (Democratic) in 2000 and the Rent(as % of GDP) in Pakistan in 2002?
Provide a short and direct response. 0.45. What is the difference between the Rent(as % of GDP) in Congo (Democratic) in 2000 and the Rent(as % of GDP) in Tunisia in 2002?
Your response must be concise. -1.25. What is the difference between the Rent(as % of GDP) of Pakistan in 2000 and the Rent(as % of GDP) of Tunisia in 2002?
Provide a short and direct response. -1.66. What is the difference between the Rent(as % of GDP) of European Union in 2000 and the Rent(as % of GDP) of Congo (Democratic) in 2003?
Ensure brevity in your answer.  -2.24. What is the difference between the Rent(as % of GDP) in European Union in 2000 and the Rent(as % of GDP) in Pakistan in 2003?
Keep it short and to the point. -0.33. What is the difference between the Rent(as % of GDP) of European Union in 2000 and the Rent(as % of GDP) of Tunisia in 2003?
Ensure brevity in your answer.  -1.82. What is the difference between the Rent(as % of GDP) in Congo (Democratic) in 2000 and the Rent(as % of GDP) in Pakistan in 2003?
Your answer should be very brief. 0.45. What is the difference between the Rent(as % of GDP) of Congo (Democratic) in 2000 and the Rent(as % of GDP) of Tunisia in 2003?
Give a very brief answer. -1.04. What is the difference between the Rent(as % of GDP) in Pakistan in 2000 and the Rent(as % of GDP) in Tunisia in 2003?
Your response must be concise. -1.46. What is the difference between the Rent(as % of GDP) of European Union in 2001 and the Rent(as % of GDP) of Congo (Democratic) in 2002?
Your answer should be very brief. -1.76. What is the difference between the Rent(as % of GDP) of European Union in 2001 and the Rent(as % of GDP) of Pakistan in 2002?
Ensure brevity in your answer.  -0.4. What is the difference between the Rent(as % of GDP) in European Union in 2001 and the Rent(as % of GDP) in Tunisia in 2002?
Offer a very short reply. -2.1. What is the difference between the Rent(as % of GDP) of Congo (Democratic) in 2001 and the Rent(as % of GDP) of Pakistan in 2002?
Give a very brief answer. 1.8. What is the difference between the Rent(as % of GDP) of Congo (Democratic) in 2001 and the Rent(as % of GDP) of Tunisia in 2002?
Give a very brief answer. 0.1. What is the difference between the Rent(as % of GDP) of Pakistan in 2001 and the Rent(as % of GDP) of Tunisia in 2002?
Make the answer very short. -1.72. What is the difference between the Rent(as % of GDP) of European Union in 2001 and the Rent(as % of GDP) of Congo (Democratic) in 2003?
Provide a short and direct response. -2.31. What is the difference between the Rent(as % of GDP) of European Union in 2001 and the Rent(as % of GDP) of Pakistan in 2003?
Make the answer very short. -0.4. What is the difference between the Rent(as % of GDP) in European Union in 2001 and the Rent(as % of GDP) in Tunisia in 2003?
Provide a succinct answer. -1.89. What is the difference between the Rent(as % of GDP) of Congo (Democratic) in 2001 and the Rent(as % of GDP) of Pakistan in 2003?
Your answer should be compact. 1.8. What is the difference between the Rent(as % of GDP) in Congo (Democratic) in 2001 and the Rent(as % of GDP) in Tunisia in 2003?
Your answer should be very brief. 0.31. What is the difference between the Rent(as % of GDP) of Pakistan in 2001 and the Rent(as % of GDP) of Tunisia in 2003?
Your answer should be very brief. -1.51. What is the difference between the Rent(as % of GDP) of European Union in 2002 and the Rent(as % of GDP) of Congo (Democratic) in 2003?
Offer a very short reply. -2.33. What is the difference between the Rent(as % of GDP) of European Union in 2002 and the Rent(as % of GDP) of Pakistan in 2003?
Provide a short and direct response. -0.41. What is the difference between the Rent(as % of GDP) in European Union in 2002 and the Rent(as % of GDP) in Tunisia in 2003?
Ensure brevity in your answer.  -1.9. What is the difference between the Rent(as % of GDP) of Congo (Democratic) in 2002 and the Rent(as % of GDP) of Pakistan in 2003?
Offer a terse response. 1.35. What is the difference between the Rent(as % of GDP) in Congo (Democratic) in 2002 and the Rent(as % of GDP) in Tunisia in 2003?
Offer a terse response. -0.14. What is the difference between the Rent(as % of GDP) of Pakistan in 2002 and the Rent(as % of GDP) of Tunisia in 2003?
Provide a short and direct response. -1.49. What is the average Rent(as % of GDP) in European Union per year?
Your answer should be compact. 0.2. What is the average Rent(as % of GDP) of Congo (Democratic) per year?
Make the answer very short. 2.25. What is the average Rent(as % of GDP) of Pakistan per year?
Ensure brevity in your answer.  0.53. What is the average Rent(as % of GDP) in Tunisia per year?
Offer a terse response. 2.24. In the year 1996, what is the difference between the Rent(as % of GDP) of European Union and Rent(as % of GDP) of Congo (Democratic)?
Offer a terse response. -2.98. In the year 1996, what is the difference between the Rent(as % of GDP) in European Union and Rent(as % of GDP) in Pakistan?
Your response must be concise. -0.36. In the year 1996, what is the difference between the Rent(as % of GDP) of European Union and Rent(as % of GDP) of Tunisia?
Keep it short and to the point. -2.59. In the year 1996, what is the difference between the Rent(as % of GDP) of Congo (Democratic) and Rent(as % of GDP) of Pakistan?
Make the answer very short. 2.62. In the year 1996, what is the difference between the Rent(as % of GDP) in Congo (Democratic) and Rent(as % of GDP) in Tunisia?
Keep it short and to the point. 0.39. In the year 1996, what is the difference between the Rent(as % of GDP) of Pakistan and Rent(as % of GDP) of Tunisia?
Provide a succinct answer. -2.23. In the year 1997, what is the difference between the Rent(as % of GDP) of European Union and Rent(as % of GDP) of Congo (Democratic)?
Offer a very short reply. -2.45. In the year 1997, what is the difference between the Rent(as % of GDP) of European Union and Rent(as % of GDP) of Pakistan?
Keep it short and to the point. -0.31. In the year 1997, what is the difference between the Rent(as % of GDP) of European Union and Rent(as % of GDP) of Tunisia?
Make the answer very short. -2.03. In the year 1997, what is the difference between the Rent(as % of GDP) of Congo (Democratic) and Rent(as % of GDP) of Pakistan?
Your answer should be compact. 2.14. In the year 1997, what is the difference between the Rent(as % of GDP) of Congo (Democratic) and Rent(as % of GDP) of Tunisia?
Provide a succinct answer. 0.42. In the year 1997, what is the difference between the Rent(as % of GDP) in Pakistan and Rent(as % of GDP) in Tunisia?
Make the answer very short. -1.71. In the year 1998, what is the difference between the Rent(as % of GDP) in European Union and Rent(as % of GDP) in Congo (Democratic)?
Make the answer very short. -1.33. In the year 1998, what is the difference between the Rent(as % of GDP) in European Union and Rent(as % of GDP) in Pakistan?
Keep it short and to the point. -0.17. In the year 1998, what is the difference between the Rent(as % of GDP) in European Union and Rent(as % of GDP) in Tunisia?
Keep it short and to the point. -1.18. In the year 1998, what is the difference between the Rent(as % of GDP) of Congo (Democratic) and Rent(as % of GDP) of Pakistan?
Make the answer very short. 1.16. In the year 1998, what is the difference between the Rent(as % of GDP) of Congo (Democratic) and Rent(as % of GDP) of Tunisia?
Give a very brief answer. 0.15. In the year 1998, what is the difference between the Rent(as % of GDP) in Pakistan and Rent(as % of GDP) in Tunisia?
Keep it short and to the point. -1.01. In the year 1999, what is the difference between the Rent(as % of GDP) of European Union and Rent(as % of GDP) of Congo (Democratic)?
Offer a terse response. -2.59. In the year 1999, what is the difference between the Rent(as % of GDP) of European Union and Rent(as % of GDP) of Pakistan?
Give a very brief answer. -0.26. In the year 1999, what is the difference between the Rent(as % of GDP) in European Union and Rent(as % of GDP) in Tunisia?
Provide a succinct answer. -1.64. In the year 1999, what is the difference between the Rent(as % of GDP) in Congo (Democratic) and Rent(as % of GDP) in Pakistan?
Ensure brevity in your answer.  2.34. In the year 1999, what is the difference between the Rent(as % of GDP) in Congo (Democratic) and Rent(as % of GDP) in Tunisia?
Your answer should be compact. 0.95. In the year 1999, what is the difference between the Rent(as % of GDP) of Pakistan and Rent(as % of GDP) of Tunisia?
Your response must be concise. -1.39. In the year 2000, what is the difference between the Rent(as % of GDP) of European Union and Rent(as % of GDP) of Congo (Democratic)?
Your response must be concise. -0.78. In the year 2000, what is the difference between the Rent(as % of GDP) in European Union and Rent(as % of GDP) in Pakistan?
Keep it short and to the point. -0.36. In the year 2000, what is the difference between the Rent(as % of GDP) in European Union and Rent(as % of GDP) in Tunisia?
Make the answer very short. -2.83. In the year 2000, what is the difference between the Rent(as % of GDP) of Congo (Democratic) and Rent(as % of GDP) of Pakistan?
Provide a short and direct response. 0.42. In the year 2000, what is the difference between the Rent(as % of GDP) in Congo (Democratic) and Rent(as % of GDP) in Tunisia?
Provide a succinct answer. -2.05. In the year 2000, what is the difference between the Rent(as % of GDP) in Pakistan and Rent(as % of GDP) in Tunisia?
Give a very brief answer. -2.47. In the year 2001, what is the difference between the Rent(as % of GDP) of European Union and Rent(as % of GDP) of Congo (Democratic)?
Provide a short and direct response. -2.2. In the year 2001, what is the difference between the Rent(as % of GDP) of European Union and Rent(as % of GDP) of Pakistan?
Your response must be concise. -0.38. In the year 2001, what is the difference between the Rent(as % of GDP) in European Union and Rent(as % of GDP) in Tunisia?
Keep it short and to the point. -2.08. In the year 2001, what is the difference between the Rent(as % of GDP) of Congo (Democratic) and Rent(as % of GDP) of Pakistan?
Your answer should be compact. 1.82. In the year 2001, what is the difference between the Rent(as % of GDP) of Congo (Democratic) and Rent(as % of GDP) of Tunisia?
Offer a terse response. 0.12. In the year 2001, what is the difference between the Rent(as % of GDP) in Pakistan and Rent(as % of GDP) in Tunisia?
Offer a very short reply. -1.69. In the year 2002, what is the difference between the Rent(as % of GDP) of European Union and Rent(as % of GDP) of Congo (Democratic)?
Keep it short and to the point. -1.77. In the year 2002, what is the difference between the Rent(as % of GDP) in European Union and Rent(as % of GDP) in Pakistan?
Ensure brevity in your answer.  -0.41. In the year 2002, what is the difference between the Rent(as % of GDP) of European Union and Rent(as % of GDP) of Tunisia?
Keep it short and to the point. -2.11. In the year 2002, what is the difference between the Rent(as % of GDP) of Congo (Democratic) and Rent(as % of GDP) of Pakistan?
Make the answer very short. 1.36. In the year 2002, what is the difference between the Rent(as % of GDP) of Congo (Democratic) and Rent(as % of GDP) of Tunisia?
Your answer should be compact. -0.35. In the year 2002, what is the difference between the Rent(as % of GDP) in Pakistan and Rent(as % of GDP) in Tunisia?
Give a very brief answer. -1.7. In the year 2003, what is the difference between the Rent(as % of GDP) of European Union and Rent(as % of GDP) of Congo (Democratic)?
Your answer should be very brief. -2.34. In the year 2003, what is the difference between the Rent(as % of GDP) of European Union and Rent(as % of GDP) of Pakistan?
Your answer should be compact. -0.43. In the year 2003, what is the difference between the Rent(as % of GDP) in European Union and Rent(as % of GDP) in Tunisia?
Provide a succinct answer. -1.92. In the year 2003, what is the difference between the Rent(as % of GDP) of Congo (Democratic) and Rent(as % of GDP) of Pakistan?
Give a very brief answer. 1.91. In the year 2003, what is the difference between the Rent(as % of GDP) of Congo (Democratic) and Rent(as % of GDP) of Tunisia?
Provide a succinct answer. 0.42. In the year 2003, what is the difference between the Rent(as % of GDP) in Pakistan and Rent(as % of GDP) in Tunisia?
Provide a short and direct response. -1.49. What is the ratio of the Rent(as % of GDP) of European Union in 1996 to that in 1997?
Ensure brevity in your answer.  1.02. What is the ratio of the Rent(as % of GDP) of Congo (Democratic) in 1996 to that in 1997?
Your answer should be very brief. 1.21. What is the ratio of the Rent(as % of GDP) of Pakistan in 1996 to that in 1997?
Provide a short and direct response. 1.1. What is the ratio of the Rent(as % of GDP) of Tunisia in 1996 to that in 1997?
Your answer should be very brief. 1.26. What is the ratio of the Rent(as % of GDP) of European Union in 1996 to that in 1998?
Your answer should be very brief. 1.85. What is the ratio of the Rent(as % of GDP) in Congo (Democratic) in 1996 to that in 1998?
Offer a terse response. 2.21. What is the ratio of the Rent(as % of GDP) in Pakistan in 1996 to that in 1998?
Your answer should be very brief. 1.98. What is the ratio of the Rent(as % of GDP) of Tunisia in 1996 to that in 1998?
Keep it short and to the point. 2.16. What is the ratio of the Rent(as % of GDP) in European Union in 1996 to that in 1999?
Your answer should be very brief. 1.2. What is the ratio of the Rent(as % of GDP) in Congo (Democratic) in 1996 to that in 1999?
Your response must be concise. 1.15. What is the ratio of the Rent(as % of GDP) in Pakistan in 1996 to that in 1999?
Provide a succinct answer. 1.33. What is the ratio of the Rent(as % of GDP) in Tunisia in 1996 to that in 1999?
Provide a short and direct response. 1.55. What is the ratio of the Rent(as % of GDP) in European Union in 1996 to that in 2000?
Provide a succinct answer. 0.64. What is the ratio of the Rent(as % of GDP) in Congo (Democratic) in 1996 to that in 2000?
Offer a terse response. 2.94. What is the ratio of the Rent(as % of GDP) of Pakistan in 1996 to that in 2000?
Your response must be concise. 0.83. What is the ratio of the Rent(as % of GDP) of Tunisia in 1996 to that in 2000?
Provide a succinct answer. 0.89. What is the ratio of the Rent(as % of GDP) in European Union in 1996 to that in 2001?
Provide a succinct answer. 0.85. What is the ratio of the Rent(as % of GDP) in Congo (Democratic) in 1996 to that in 2001?
Provide a short and direct response. 1.31. What is the ratio of the Rent(as % of GDP) in Pakistan in 1996 to that in 2001?
Make the answer very short. 0.91. What is the ratio of the Rent(as % of GDP) of Tunisia in 1996 to that in 2001?
Offer a terse response. 1.21. What is the ratio of the Rent(as % of GDP) of European Union in 1996 to that in 2002?
Offer a terse response. 0.9. What is the ratio of the Rent(as % of GDP) of Congo (Democratic) in 1996 to that in 2002?
Give a very brief answer. 1.6. What is the ratio of the Rent(as % of GDP) in Pakistan in 1996 to that in 2002?
Your response must be concise. 0.88. What is the ratio of the Rent(as % of GDP) in Tunisia in 1996 to that in 2002?
Provide a succinct answer. 1.2. What is the ratio of the Rent(as % of GDP) in European Union in 1996 to that in 2003?
Offer a terse response. 0.98. What is the ratio of the Rent(as % of GDP) of Congo (Democratic) in 1996 to that in 2003?
Make the answer very short. 1.25. What is the ratio of the Rent(as % of GDP) in Pakistan in 1996 to that in 2003?
Your answer should be very brief. 0.88. What is the ratio of the Rent(as % of GDP) of Tunisia in 1996 to that in 2003?
Offer a terse response. 1.31. What is the ratio of the Rent(as % of GDP) of European Union in 1997 to that in 1998?
Ensure brevity in your answer.  1.81. What is the ratio of the Rent(as % of GDP) in Congo (Democratic) in 1997 to that in 1998?
Your response must be concise. 1.84. What is the ratio of the Rent(as % of GDP) in Pakistan in 1997 to that in 1998?
Give a very brief answer. 1.79. What is the ratio of the Rent(as % of GDP) in Tunisia in 1997 to that in 1998?
Offer a very short reply. 1.72. What is the ratio of the Rent(as % of GDP) of European Union in 1997 to that in 1999?
Offer a very short reply. 1.18. What is the ratio of the Rent(as % of GDP) of Congo (Democratic) in 1997 to that in 1999?
Your answer should be compact. 0.96. What is the ratio of the Rent(as % of GDP) of Pakistan in 1997 to that in 1999?
Your answer should be very brief. 1.2. What is the ratio of the Rent(as % of GDP) of Tunisia in 1997 to that in 1999?
Offer a terse response. 1.23. What is the ratio of the Rent(as % of GDP) in European Union in 1997 to that in 2000?
Your response must be concise. 0.62. What is the ratio of the Rent(as % of GDP) of Congo (Democratic) in 1997 to that in 2000?
Offer a very short reply. 2.44. What is the ratio of the Rent(as % of GDP) in Pakistan in 1997 to that in 2000?
Give a very brief answer. 0.76. What is the ratio of the Rent(as % of GDP) in Tunisia in 1997 to that in 2000?
Offer a very short reply. 0.71. What is the ratio of the Rent(as % of GDP) in European Union in 1997 to that in 2001?
Give a very brief answer. 0.83. What is the ratio of the Rent(as % of GDP) in Congo (Democratic) in 1997 to that in 2001?
Make the answer very short. 1.09. What is the ratio of the Rent(as % of GDP) in Pakistan in 1997 to that in 2001?
Your answer should be compact. 0.82. What is the ratio of the Rent(as % of GDP) in Tunisia in 1997 to that in 2001?
Your answer should be very brief. 0.96. What is the ratio of the Rent(as % of GDP) in European Union in 1997 to that in 2002?
Make the answer very short. 0.88. What is the ratio of the Rent(as % of GDP) of Congo (Democratic) in 1997 to that in 2002?
Offer a very short reply. 1.33. What is the ratio of the Rent(as % of GDP) in Pakistan in 1997 to that in 2002?
Provide a short and direct response. 0.8. What is the ratio of the Rent(as % of GDP) in Tunisia in 1997 to that in 2002?
Offer a very short reply. 0.95. What is the ratio of the Rent(as % of GDP) in European Union in 1997 to that in 2003?
Provide a succinct answer. 0.95. What is the ratio of the Rent(as % of GDP) in Congo (Democratic) in 1997 to that in 2003?
Offer a terse response. 1.04. What is the ratio of the Rent(as % of GDP) in Pakistan in 1997 to that in 2003?
Your answer should be very brief. 0.8. What is the ratio of the Rent(as % of GDP) in Tunisia in 1997 to that in 2003?
Your answer should be very brief. 1.04. What is the ratio of the Rent(as % of GDP) of European Union in 1998 to that in 1999?
Ensure brevity in your answer.  0.65. What is the ratio of the Rent(as % of GDP) of Congo (Democratic) in 1998 to that in 1999?
Give a very brief answer. 0.52. What is the ratio of the Rent(as % of GDP) in Pakistan in 1998 to that in 1999?
Provide a succinct answer. 0.67. What is the ratio of the Rent(as % of GDP) in Tunisia in 1998 to that in 1999?
Give a very brief answer. 0.72. What is the ratio of the Rent(as % of GDP) of European Union in 1998 to that in 2000?
Your answer should be compact. 0.34. What is the ratio of the Rent(as % of GDP) in Congo (Democratic) in 1998 to that in 2000?
Your answer should be very brief. 1.33. What is the ratio of the Rent(as % of GDP) of Pakistan in 1998 to that in 2000?
Offer a very short reply. 0.42. What is the ratio of the Rent(as % of GDP) of Tunisia in 1998 to that in 2000?
Give a very brief answer. 0.41. What is the ratio of the Rent(as % of GDP) of European Union in 1998 to that in 2001?
Your response must be concise. 0.46. What is the ratio of the Rent(as % of GDP) of Congo (Democratic) in 1998 to that in 2001?
Offer a terse response. 0.59. What is the ratio of the Rent(as % of GDP) in Pakistan in 1998 to that in 2001?
Ensure brevity in your answer.  0.46. What is the ratio of the Rent(as % of GDP) in Tunisia in 1998 to that in 2001?
Offer a terse response. 0.56. What is the ratio of the Rent(as % of GDP) in European Union in 1998 to that in 2002?
Your answer should be very brief. 0.49. What is the ratio of the Rent(as % of GDP) of Congo (Democratic) in 1998 to that in 2002?
Offer a terse response. 0.72. What is the ratio of the Rent(as % of GDP) of Pakistan in 1998 to that in 2002?
Your response must be concise. 0.45. What is the ratio of the Rent(as % of GDP) of Tunisia in 1998 to that in 2002?
Ensure brevity in your answer.  0.55. What is the ratio of the Rent(as % of GDP) of European Union in 1998 to that in 2003?
Offer a terse response. 0.53. What is the ratio of the Rent(as % of GDP) of Congo (Democratic) in 1998 to that in 2003?
Your response must be concise. 0.57. What is the ratio of the Rent(as % of GDP) in Pakistan in 1998 to that in 2003?
Provide a succinct answer. 0.44. What is the ratio of the Rent(as % of GDP) of Tunisia in 1998 to that in 2003?
Offer a very short reply. 0.61. What is the ratio of the Rent(as % of GDP) in European Union in 1999 to that in 2000?
Keep it short and to the point. 0.53. What is the ratio of the Rent(as % of GDP) in Congo (Democratic) in 1999 to that in 2000?
Offer a terse response. 2.55. What is the ratio of the Rent(as % of GDP) of Pakistan in 1999 to that in 2000?
Provide a succinct answer. 0.63. What is the ratio of the Rent(as % of GDP) in Tunisia in 1999 to that in 2000?
Make the answer very short. 0.57. What is the ratio of the Rent(as % of GDP) in European Union in 1999 to that in 2001?
Provide a succinct answer. 0.71. What is the ratio of the Rent(as % of GDP) of Congo (Democratic) in 1999 to that in 2001?
Keep it short and to the point. 1.14. What is the ratio of the Rent(as % of GDP) of Pakistan in 1999 to that in 2001?
Give a very brief answer. 0.68. What is the ratio of the Rent(as % of GDP) of Tunisia in 1999 to that in 2001?
Make the answer very short. 0.78. What is the ratio of the Rent(as % of GDP) in European Union in 1999 to that in 2002?
Provide a succinct answer. 0.75. What is the ratio of the Rent(as % of GDP) in Congo (Democratic) in 1999 to that in 2002?
Keep it short and to the point. 1.39. What is the ratio of the Rent(as % of GDP) in Pakistan in 1999 to that in 2002?
Make the answer very short. 0.66. What is the ratio of the Rent(as % of GDP) of Tunisia in 1999 to that in 2002?
Ensure brevity in your answer.  0.77. What is the ratio of the Rent(as % of GDP) in European Union in 1999 to that in 2003?
Keep it short and to the point. 0.81. What is the ratio of the Rent(as % of GDP) in Congo (Democratic) in 1999 to that in 2003?
Give a very brief answer. 1.08. What is the ratio of the Rent(as % of GDP) in Pakistan in 1999 to that in 2003?
Give a very brief answer. 0.66. What is the ratio of the Rent(as % of GDP) in Tunisia in 1999 to that in 2003?
Your answer should be very brief. 0.85. What is the ratio of the Rent(as % of GDP) in European Union in 2000 to that in 2001?
Provide a short and direct response. 1.34. What is the ratio of the Rent(as % of GDP) of Congo (Democratic) in 2000 to that in 2001?
Keep it short and to the point. 0.45. What is the ratio of the Rent(as % of GDP) in Pakistan in 2000 to that in 2001?
Give a very brief answer. 1.09. What is the ratio of the Rent(as % of GDP) of Tunisia in 2000 to that in 2001?
Provide a succinct answer. 1.36. What is the ratio of the Rent(as % of GDP) in European Union in 2000 to that in 2002?
Offer a terse response. 1.41. What is the ratio of the Rent(as % of GDP) in Congo (Democratic) in 2000 to that in 2002?
Make the answer very short. 0.55. What is the ratio of the Rent(as % of GDP) of Pakistan in 2000 to that in 2002?
Your answer should be compact. 1.06. What is the ratio of the Rent(as % of GDP) in Tunisia in 2000 to that in 2002?
Provide a short and direct response. 1.35. What is the ratio of the Rent(as % of GDP) of European Union in 2000 to that in 2003?
Provide a succinct answer. 1.54. What is the ratio of the Rent(as % of GDP) in Congo (Democratic) in 2000 to that in 2003?
Give a very brief answer. 0.43. What is the ratio of the Rent(as % of GDP) of Pakistan in 2000 to that in 2003?
Make the answer very short. 1.05. What is the ratio of the Rent(as % of GDP) of Tunisia in 2000 to that in 2003?
Your answer should be very brief. 1.48. What is the ratio of the Rent(as % of GDP) in European Union in 2001 to that in 2002?
Offer a terse response. 1.05. What is the ratio of the Rent(as % of GDP) of Congo (Democratic) in 2001 to that in 2002?
Your response must be concise. 1.22. What is the ratio of the Rent(as % of GDP) in Pakistan in 2001 to that in 2002?
Offer a terse response. 0.97. What is the ratio of the Rent(as % of GDP) of Tunisia in 2001 to that in 2002?
Your answer should be compact. 0.99. What is the ratio of the Rent(as % of GDP) in European Union in 2001 to that in 2003?
Provide a short and direct response. 1.15. What is the ratio of the Rent(as % of GDP) of Congo (Democratic) in 2001 to that in 2003?
Ensure brevity in your answer.  0.95. What is the ratio of the Rent(as % of GDP) of Pakistan in 2001 to that in 2003?
Provide a succinct answer. 0.97. What is the ratio of the Rent(as % of GDP) in Tunisia in 2001 to that in 2003?
Your answer should be very brief. 1.09. What is the ratio of the Rent(as % of GDP) in European Union in 2002 to that in 2003?
Your answer should be very brief. 1.09. What is the ratio of the Rent(as % of GDP) of Congo (Democratic) in 2002 to that in 2003?
Keep it short and to the point. 0.78. What is the ratio of the Rent(as % of GDP) of Pakistan in 2002 to that in 2003?
Ensure brevity in your answer.  1. What is the ratio of the Rent(as % of GDP) in Tunisia in 2002 to that in 2003?
Ensure brevity in your answer.  1.1. What is the difference between the highest and the second highest Rent(as % of GDP) in European Union?
Offer a very short reply. 0.08. What is the difference between the highest and the second highest Rent(as % of GDP) of Congo (Democratic)?
Offer a very short reply. 0.42. What is the difference between the highest and the second highest Rent(as % of GDP) of Pakistan?
Provide a succinct answer. 0.03. What is the difference between the highest and the second highest Rent(as % of GDP) in Tunisia?
Make the answer very short. 0.35. What is the difference between the highest and the lowest Rent(as % of GDP) in European Union?
Offer a very short reply. 0.2. What is the difference between the highest and the lowest Rent(as % of GDP) of Congo (Democratic)?
Your answer should be compact. 2.1. What is the difference between the highest and the lowest Rent(as % of GDP) in Pakistan?
Your answer should be compact. 0.38. What is the difference between the highest and the lowest Rent(as % of GDP) of Tunisia?
Provide a succinct answer. 1.84. 